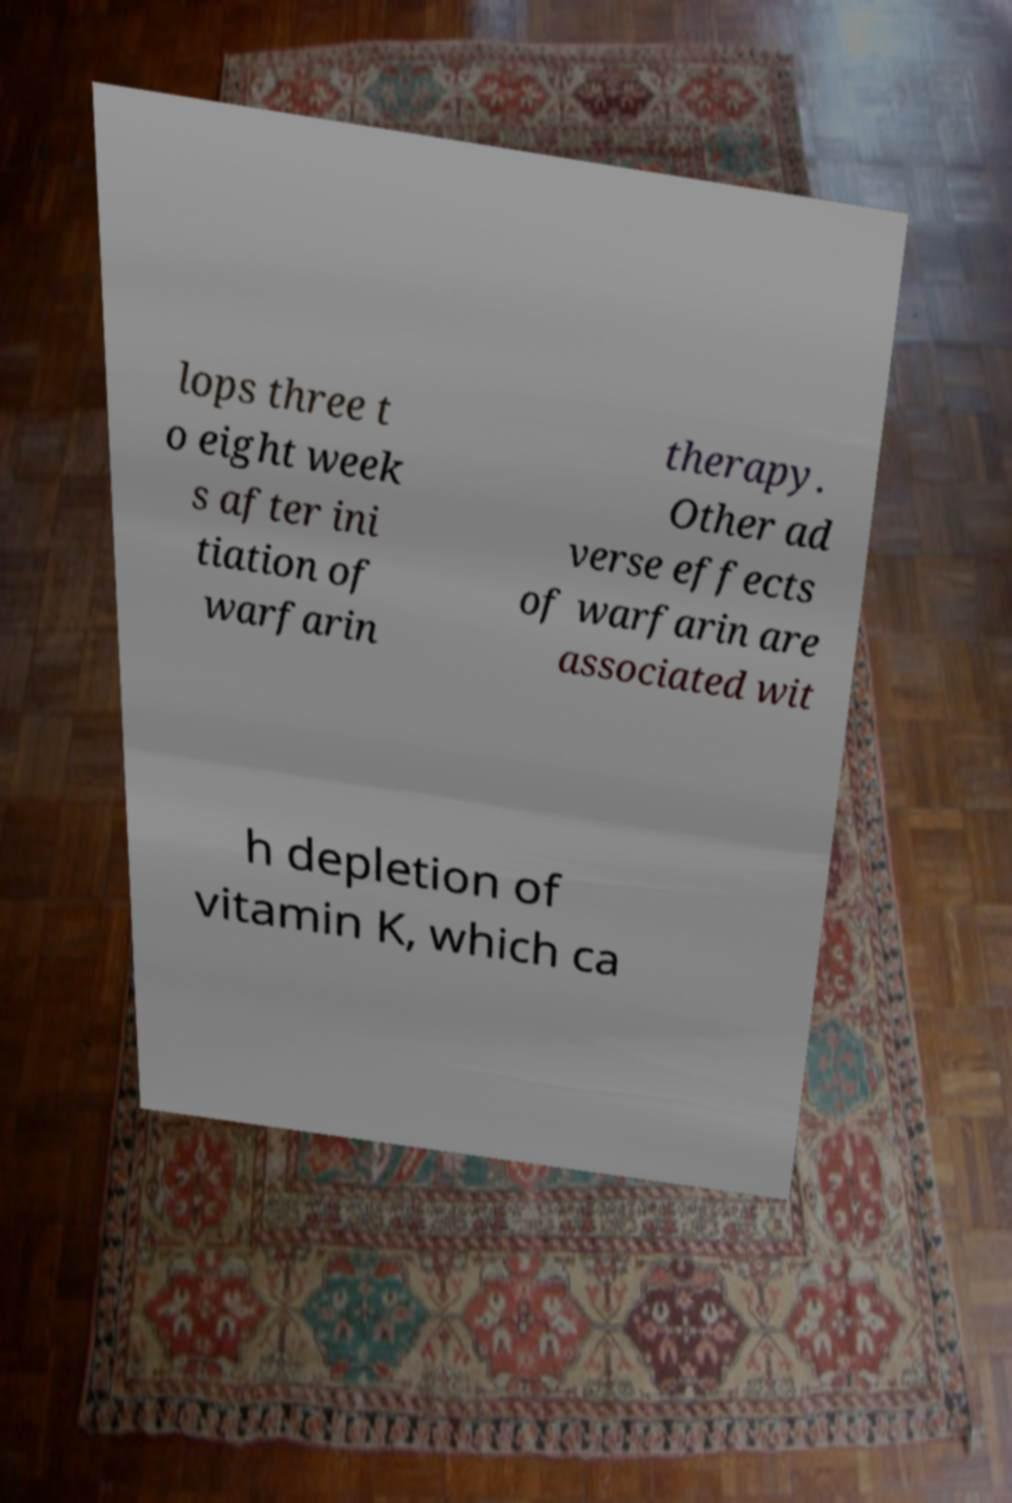Can you read and provide the text displayed in the image?This photo seems to have some interesting text. Can you extract and type it out for me? lops three t o eight week s after ini tiation of warfarin therapy. Other ad verse effects of warfarin are associated wit h depletion of vitamin K, which ca 